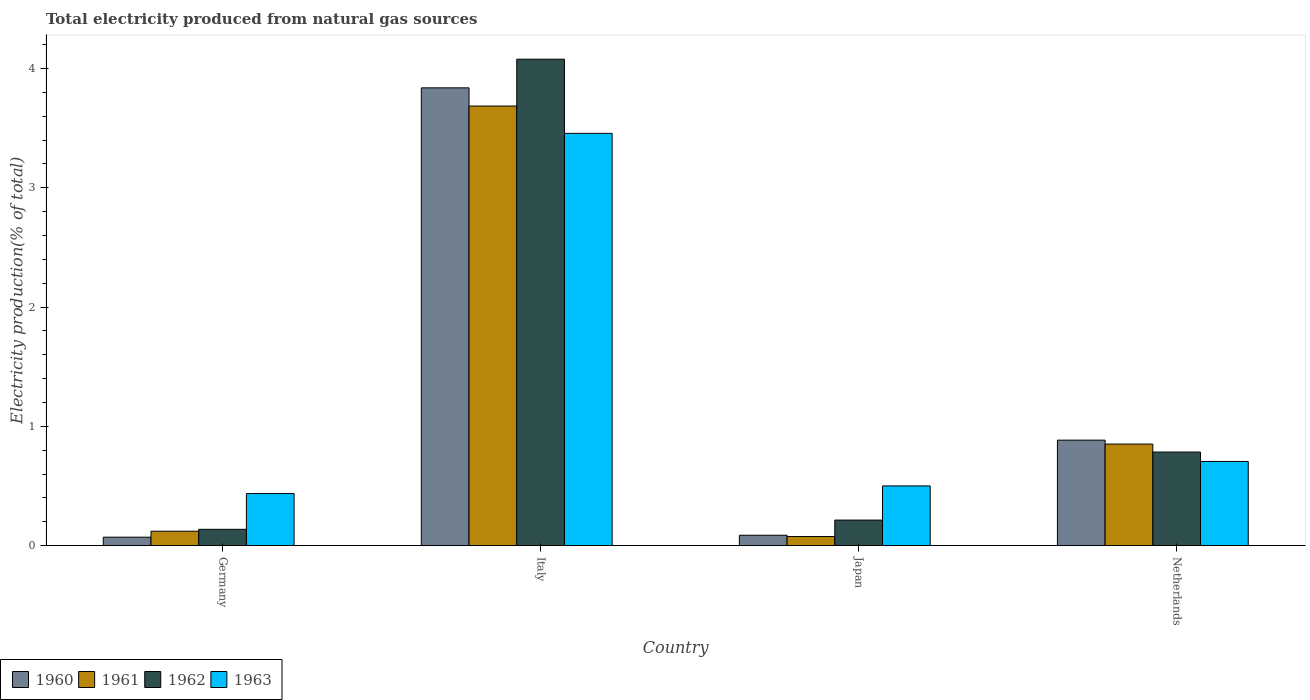Are the number of bars per tick equal to the number of legend labels?
Offer a very short reply. Yes. How many bars are there on the 1st tick from the right?
Provide a succinct answer. 4. What is the label of the 3rd group of bars from the left?
Provide a short and direct response. Japan. In how many cases, is the number of bars for a given country not equal to the number of legend labels?
Provide a short and direct response. 0. What is the total electricity produced in 1960 in Germany?
Offer a terse response. 0.07. Across all countries, what is the maximum total electricity produced in 1960?
Ensure brevity in your answer.  3.84. Across all countries, what is the minimum total electricity produced in 1960?
Provide a succinct answer. 0.07. In which country was the total electricity produced in 1963 maximum?
Provide a succinct answer. Italy. In which country was the total electricity produced in 1961 minimum?
Keep it short and to the point. Japan. What is the total total electricity produced in 1960 in the graph?
Offer a terse response. 4.88. What is the difference between the total electricity produced in 1960 in Japan and that in Netherlands?
Keep it short and to the point. -0.8. What is the difference between the total electricity produced in 1960 in Netherlands and the total electricity produced in 1962 in Japan?
Provide a succinct answer. 0.67. What is the average total electricity produced in 1963 per country?
Keep it short and to the point. 1.27. What is the difference between the total electricity produced of/in 1961 and total electricity produced of/in 1960 in Japan?
Your answer should be very brief. -0.01. In how many countries, is the total electricity produced in 1961 greater than 1.2 %?
Your answer should be compact. 1. What is the ratio of the total electricity produced in 1963 in Italy to that in Netherlands?
Give a very brief answer. 4.9. Is the difference between the total electricity produced in 1961 in Italy and Netherlands greater than the difference between the total electricity produced in 1960 in Italy and Netherlands?
Provide a succinct answer. No. What is the difference between the highest and the second highest total electricity produced in 1963?
Your answer should be very brief. 0.21. What is the difference between the highest and the lowest total electricity produced in 1961?
Ensure brevity in your answer.  3.61. Is the sum of the total electricity produced in 1960 in Italy and Netherlands greater than the maximum total electricity produced in 1961 across all countries?
Keep it short and to the point. Yes. What does the 1st bar from the left in Germany represents?
Your response must be concise. 1960. What does the 3rd bar from the right in Germany represents?
Keep it short and to the point. 1961. Are the values on the major ticks of Y-axis written in scientific E-notation?
Make the answer very short. No. What is the title of the graph?
Give a very brief answer. Total electricity produced from natural gas sources. What is the label or title of the X-axis?
Provide a short and direct response. Country. What is the Electricity production(% of total) of 1960 in Germany?
Provide a succinct answer. 0.07. What is the Electricity production(% of total) in 1961 in Germany?
Your response must be concise. 0.12. What is the Electricity production(% of total) in 1962 in Germany?
Keep it short and to the point. 0.14. What is the Electricity production(% of total) of 1963 in Germany?
Ensure brevity in your answer.  0.44. What is the Electricity production(% of total) of 1960 in Italy?
Provide a succinct answer. 3.84. What is the Electricity production(% of total) in 1961 in Italy?
Your answer should be very brief. 3.69. What is the Electricity production(% of total) in 1962 in Italy?
Your response must be concise. 4.08. What is the Electricity production(% of total) in 1963 in Italy?
Your answer should be very brief. 3.46. What is the Electricity production(% of total) in 1960 in Japan?
Keep it short and to the point. 0.09. What is the Electricity production(% of total) of 1961 in Japan?
Offer a terse response. 0.08. What is the Electricity production(% of total) of 1962 in Japan?
Offer a terse response. 0.21. What is the Electricity production(% of total) of 1963 in Japan?
Offer a terse response. 0.5. What is the Electricity production(% of total) in 1960 in Netherlands?
Offer a terse response. 0.88. What is the Electricity production(% of total) of 1961 in Netherlands?
Keep it short and to the point. 0.85. What is the Electricity production(% of total) in 1962 in Netherlands?
Your response must be concise. 0.78. What is the Electricity production(% of total) of 1963 in Netherlands?
Provide a succinct answer. 0.71. Across all countries, what is the maximum Electricity production(% of total) of 1960?
Provide a short and direct response. 3.84. Across all countries, what is the maximum Electricity production(% of total) in 1961?
Provide a short and direct response. 3.69. Across all countries, what is the maximum Electricity production(% of total) of 1962?
Make the answer very short. 4.08. Across all countries, what is the maximum Electricity production(% of total) in 1963?
Your response must be concise. 3.46. Across all countries, what is the minimum Electricity production(% of total) of 1960?
Make the answer very short. 0.07. Across all countries, what is the minimum Electricity production(% of total) of 1961?
Make the answer very short. 0.08. Across all countries, what is the minimum Electricity production(% of total) in 1962?
Ensure brevity in your answer.  0.14. Across all countries, what is the minimum Electricity production(% of total) in 1963?
Provide a succinct answer. 0.44. What is the total Electricity production(% of total) of 1960 in the graph?
Offer a very short reply. 4.88. What is the total Electricity production(% of total) of 1961 in the graph?
Offer a terse response. 4.73. What is the total Electricity production(% of total) in 1962 in the graph?
Ensure brevity in your answer.  5.21. What is the total Electricity production(% of total) in 1963 in the graph?
Offer a very short reply. 5.1. What is the difference between the Electricity production(% of total) of 1960 in Germany and that in Italy?
Offer a terse response. -3.77. What is the difference between the Electricity production(% of total) of 1961 in Germany and that in Italy?
Your answer should be very brief. -3.57. What is the difference between the Electricity production(% of total) in 1962 in Germany and that in Italy?
Keep it short and to the point. -3.94. What is the difference between the Electricity production(% of total) of 1963 in Germany and that in Italy?
Keep it short and to the point. -3.02. What is the difference between the Electricity production(% of total) in 1960 in Germany and that in Japan?
Make the answer very short. -0.02. What is the difference between the Electricity production(% of total) in 1961 in Germany and that in Japan?
Your answer should be very brief. 0.04. What is the difference between the Electricity production(% of total) of 1962 in Germany and that in Japan?
Provide a short and direct response. -0.08. What is the difference between the Electricity production(% of total) in 1963 in Germany and that in Japan?
Keep it short and to the point. -0.06. What is the difference between the Electricity production(% of total) of 1960 in Germany and that in Netherlands?
Make the answer very short. -0.81. What is the difference between the Electricity production(% of total) in 1961 in Germany and that in Netherlands?
Make the answer very short. -0.73. What is the difference between the Electricity production(% of total) in 1962 in Germany and that in Netherlands?
Your answer should be compact. -0.65. What is the difference between the Electricity production(% of total) of 1963 in Germany and that in Netherlands?
Give a very brief answer. -0.27. What is the difference between the Electricity production(% of total) of 1960 in Italy and that in Japan?
Give a very brief answer. 3.75. What is the difference between the Electricity production(% of total) in 1961 in Italy and that in Japan?
Offer a very short reply. 3.61. What is the difference between the Electricity production(% of total) in 1962 in Italy and that in Japan?
Your answer should be compact. 3.86. What is the difference between the Electricity production(% of total) of 1963 in Italy and that in Japan?
Your response must be concise. 2.96. What is the difference between the Electricity production(% of total) in 1960 in Italy and that in Netherlands?
Keep it short and to the point. 2.95. What is the difference between the Electricity production(% of total) in 1961 in Italy and that in Netherlands?
Give a very brief answer. 2.83. What is the difference between the Electricity production(% of total) in 1962 in Italy and that in Netherlands?
Your answer should be compact. 3.29. What is the difference between the Electricity production(% of total) in 1963 in Italy and that in Netherlands?
Offer a terse response. 2.75. What is the difference between the Electricity production(% of total) in 1960 in Japan and that in Netherlands?
Make the answer very short. -0.8. What is the difference between the Electricity production(% of total) in 1961 in Japan and that in Netherlands?
Ensure brevity in your answer.  -0.78. What is the difference between the Electricity production(% of total) in 1962 in Japan and that in Netherlands?
Offer a terse response. -0.57. What is the difference between the Electricity production(% of total) of 1963 in Japan and that in Netherlands?
Give a very brief answer. -0.21. What is the difference between the Electricity production(% of total) of 1960 in Germany and the Electricity production(% of total) of 1961 in Italy?
Provide a succinct answer. -3.62. What is the difference between the Electricity production(% of total) of 1960 in Germany and the Electricity production(% of total) of 1962 in Italy?
Provide a succinct answer. -4.01. What is the difference between the Electricity production(% of total) of 1960 in Germany and the Electricity production(% of total) of 1963 in Italy?
Your response must be concise. -3.39. What is the difference between the Electricity production(% of total) in 1961 in Germany and the Electricity production(% of total) in 1962 in Italy?
Your response must be concise. -3.96. What is the difference between the Electricity production(% of total) of 1961 in Germany and the Electricity production(% of total) of 1963 in Italy?
Give a very brief answer. -3.34. What is the difference between the Electricity production(% of total) in 1962 in Germany and the Electricity production(% of total) in 1963 in Italy?
Give a very brief answer. -3.32. What is the difference between the Electricity production(% of total) of 1960 in Germany and the Electricity production(% of total) of 1961 in Japan?
Your response must be concise. -0.01. What is the difference between the Electricity production(% of total) of 1960 in Germany and the Electricity production(% of total) of 1962 in Japan?
Provide a succinct answer. -0.14. What is the difference between the Electricity production(% of total) in 1960 in Germany and the Electricity production(% of total) in 1963 in Japan?
Provide a short and direct response. -0.43. What is the difference between the Electricity production(% of total) in 1961 in Germany and the Electricity production(% of total) in 1962 in Japan?
Keep it short and to the point. -0.09. What is the difference between the Electricity production(% of total) in 1961 in Germany and the Electricity production(% of total) in 1963 in Japan?
Ensure brevity in your answer.  -0.38. What is the difference between the Electricity production(% of total) of 1962 in Germany and the Electricity production(% of total) of 1963 in Japan?
Provide a succinct answer. -0.36. What is the difference between the Electricity production(% of total) in 1960 in Germany and the Electricity production(% of total) in 1961 in Netherlands?
Offer a very short reply. -0.78. What is the difference between the Electricity production(% of total) in 1960 in Germany and the Electricity production(% of total) in 1962 in Netherlands?
Make the answer very short. -0.71. What is the difference between the Electricity production(% of total) in 1960 in Germany and the Electricity production(% of total) in 1963 in Netherlands?
Keep it short and to the point. -0.64. What is the difference between the Electricity production(% of total) of 1961 in Germany and the Electricity production(% of total) of 1962 in Netherlands?
Your answer should be compact. -0.66. What is the difference between the Electricity production(% of total) in 1961 in Germany and the Electricity production(% of total) in 1963 in Netherlands?
Your answer should be compact. -0.58. What is the difference between the Electricity production(% of total) in 1962 in Germany and the Electricity production(% of total) in 1963 in Netherlands?
Offer a terse response. -0.57. What is the difference between the Electricity production(% of total) in 1960 in Italy and the Electricity production(% of total) in 1961 in Japan?
Offer a terse response. 3.76. What is the difference between the Electricity production(% of total) of 1960 in Italy and the Electricity production(% of total) of 1962 in Japan?
Your response must be concise. 3.62. What is the difference between the Electricity production(% of total) in 1960 in Italy and the Electricity production(% of total) in 1963 in Japan?
Offer a very short reply. 3.34. What is the difference between the Electricity production(% of total) of 1961 in Italy and the Electricity production(% of total) of 1962 in Japan?
Provide a succinct answer. 3.47. What is the difference between the Electricity production(% of total) of 1961 in Italy and the Electricity production(% of total) of 1963 in Japan?
Keep it short and to the point. 3.19. What is the difference between the Electricity production(% of total) of 1962 in Italy and the Electricity production(% of total) of 1963 in Japan?
Offer a very short reply. 3.58. What is the difference between the Electricity production(% of total) of 1960 in Italy and the Electricity production(% of total) of 1961 in Netherlands?
Make the answer very short. 2.99. What is the difference between the Electricity production(% of total) of 1960 in Italy and the Electricity production(% of total) of 1962 in Netherlands?
Provide a succinct answer. 3.05. What is the difference between the Electricity production(% of total) in 1960 in Italy and the Electricity production(% of total) in 1963 in Netherlands?
Give a very brief answer. 3.13. What is the difference between the Electricity production(% of total) in 1961 in Italy and the Electricity production(% of total) in 1962 in Netherlands?
Keep it short and to the point. 2.9. What is the difference between the Electricity production(% of total) in 1961 in Italy and the Electricity production(% of total) in 1963 in Netherlands?
Provide a succinct answer. 2.98. What is the difference between the Electricity production(% of total) of 1962 in Italy and the Electricity production(% of total) of 1963 in Netherlands?
Provide a short and direct response. 3.37. What is the difference between the Electricity production(% of total) of 1960 in Japan and the Electricity production(% of total) of 1961 in Netherlands?
Keep it short and to the point. -0.76. What is the difference between the Electricity production(% of total) of 1960 in Japan and the Electricity production(% of total) of 1962 in Netherlands?
Make the answer very short. -0.7. What is the difference between the Electricity production(% of total) of 1960 in Japan and the Electricity production(% of total) of 1963 in Netherlands?
Your response must be concise. -0.62. What is the difference between the Electricity production(% of total) of 1961 in Japan and the Electricity production(% of total) of 1962 in Netherlands?
Provide a short and direct response. -0.71. What is the difference between the Electricity production(% of total) in 1961 in Japan and the Electricity production(% of total) in 1963 in Netherlands?
Give a very brief answer. -0.63. What is the difference between the Electricity production(% of total) of 1962 in Japan and the Electricity production(% of total) of 1963 in Netherlands?
Keep it short and to the point. -0.49. What is the average Electricity production(% of total) in 1960 per country?
Keep it short and to the point. 1.22. What is the average Electricity production(% of total) in 1961 per country?
Provide a short and direct response. 1.18. What is the average Electricity production(% of total) in 1962 per country?
Make the answer very short. 1.3. What is the average Electricity production(% of total) in 1963 per country?
Make the answer very short. 1.27. What is the difference between the Electricity production(% of total) in 1960 and Electricity production(% of total) in 1962 in Germany?
Your answer should be very brief. -0.07. What is the difference between the Electricity production(% of total) of 1960 and Electricity production(% of total) of 1963 in Germany?
Give a very brief answer. -0.37. What is the difference between the Electricity production(% of total) of 1961 and Electricity production(% of total) of 1962 in Germany?
Ensure brevity in your answer.  -0.02. What is the difference between the Electricity production(% of total) of 1961 and Electricity production(% of total) of 1963 in Germany?
Provide a short and direct response. -0.32. What is the difference between the Electricity production(% of total) in 1962 and Electricity production(% of total) in 1963 in Germany?
Your answer should be compact. -0.3. What is the difference between the Electricity production(% of total) in 1960 and Electricity production(% of total) in 1961 in Italy?
Offer a very short reply. 0.15. What is the difference between the Electricity production(% of total) in 1960 and Electricity production(% of total) in 1962 in Italy?
Provide a short and direct response. -0.24. What is the difference between the Electricity production(% of total) of 1960 and Electricity production(% of total) of 1963 in Italy?
Ensure brevity in your answer.  0.38. What is the difference between the Electricity production(% of total) of 1961 and Electricity production(% of total) of 1962 in Italy?
Provide a short and direct response. -0.39. What is the difference between the Electricity production(% of total) of 1961 and Electricity production(% of total) of 1963 in Italy?
Make the answer very short. 0.23. What is the difference between the Electricity production(% of total) of 1962 and Electricity production(% of total) of 1963 in Italy?
Offer a very short reply. 0.62. What is the difference between the Electricity production(% of total) in 1960 and Electricity production(% of total) in 1961 in Japan?
Your answer should be compact. 0.01. What is the difference between the Electricity production(% of total) in 1960 and Electricity production(% of total) in 1962 in Japan?
Your response must be concise. -0.13. What is the difference between the Electricity production(% of total) of 1960 and Electricity production(% of total) of 1963 in Japan?
Provide a short and direct response. -0.41. What is the difference between the Electricity production(% of total) of 1961 and Electricity production(% of total) of 1962 in Japan?
Make the answer very short. -0.14. What is the difference between the Electricity production(% of total) of 1961 and Electricity production(% of total) of 1963 in Japan?
Keep it short and to the point. -0.42. What is the difference between the Electricity production(% of total) of 1962 and Electricity production(% of total) of 1963 in Japan?
Provide a short and direct response. -0.29. What is the difference between the Electricity production(% of total) in 1960 and Electricity production(% of total) in 1961 in Netherlands?
Your answer should be very brief. 0.03. What is the difference between the Electricity production(% of total) in 1960 and Electricity production(% of total) in 1962 in Netherlands?
Your response must be concise. 0.1. What is the difference between the Electricity production(% of total) of 1960 and Electricity production(% of total) of 1963 in Netherlands?
Ensure brevity in your answer.  0.18. What is the difference between the Electricity production(% of total) in 1961 and Electricity production(% of total) in 1962 in Netherlands?
Your answer should be compact. 0.07. What is the difference between the Electricity production(% of total) of 1961 and Electricity production(% of total) of 1963 in Netherlands?
Your answer should be compact. 0.15. What is the difference between the Electricity production(% of total) of 1962 and Electricity production(% of total) of 1963 in Netherlands?
Offer a terse response. 0.08. What is the ratio of the Electricity production(% of total) of 1960 in Germany to that in Italy?
Your answer should be very brief. 0.02. What is the ratio of the Electricity production(% of total) of 1961 in Germany to that in Italy?
Provide a short and direct response. 0.03. What is the ratio of the Electricity production(% of total) of 1962 in Germany to that in Italy?
Ensure brevity in your answer.  0.03. What is the ratio of the Electricity production(% of total) of 1963 in Germany to that in Italy?
Ensure brevity in your answer.  0.13. What is the ratio of the Electricity production(% of total) of 1960 in Germany to that in Japan?
Offer a terse response. 0.81. What is the ratio of the Electricity production(% of total) of 1961 in Germany to that in Japan?
Your response must be concise. 1.59. What is the ratio of the Electricity production(% of total) in 1962 in Germany to that in Japan?
Your answer should be very brief. 0.64. What is the ratio of the Electricity production(% of total) in 1963 in Germany to that in Japan?
Your answer should be compact. 0.87. What is the ratio of the Electricity production(% of total) of 1960 in Germany to that in Netherlands?
Your answer should be very brief. 0.08. What is the ratio of the Electricity production(% of total) in 1961 in Germany to that in Netherlands?
Your answer should be very brief. 0.14. What is the ratio of the Electricity production(% of total) in 1962 in Germany to that in Netherlands?
Keep it short and to the point. 0.17. What is the ratio of the Electricity production(% of total) of 1963 in Germany to that in Netherlands?
Offer a very short reply. 0.62. What is the ratio of the Electricity production(% of total) in 1960 in Italy to that in Japan?
Your answer should be compact. 44.33. What is the ratio of the Electricity production(% of total) of 1961 in Italy to that in Japan?
Your response must be concise. 48.69. What is the ratio of the Electricity production(% of total) in 1962 in Italy to that in Japan?
Offer a terse response. 19.09. What is the ratio of the Electricity production(% of total) in 1963 in Italy to that in Japan?
Provide a short and direct response. 6.91. What is the ratio of the Electricity production(% of total) of 1960 in Italy to that in Netherlands?
Provide a succinct answer. 4.34. What is the ratio of the Electricity production(% of total) of 1961 in Italy to that in Netherlands?
Give a very brief answer. 4.33. What is the ratio of the Electricity production(% of total) of 1962 in Italy to that in Netherlands?
Offer a very short reply. 5.2. What is the ratio of the Electricity production(% of total) in 1963 in Italy to that in Netherlands?
Your answer should be very brief. 4.9. What is the ratio of the Electricity production(% of total) in 1960 in Japan to that in Netherlands?
Offer a terse response. 0.1. What is the ratio of the Electricity production(% of total) of 1961 in Japan to that in Netherlands?
Your answer should be compact. 0.09. What is the ratio of the Electricity production(% of total) of 1962 in Japan to that in Netherlands?
Give a very brief answer. 0.27. What is the ratio of the Electricity production(% of total) of 1963 in Japan to that in Netherlands?
Provide a succinct answer. 0.71. What is the difference between the highest and the second highest Electricity production(% of total) in 1960?
Your answer should be very brief. 2.95. What is the difference between the highest and the second highest Electricity production(% of total) in 1961?
Offer a terse response. 2.83. What is the difference between the highest and the second highest Electricity production(% of total) of 1962?
Provide a short and direct response. 3.29. What is the difference between the highest and the second highest Electricity production(% of total) of 1963?
Your answer should be compact. 2.75. What is the difference between the highest and the lowest Electricity production(% of total) in 1960?
Provide a succinct answer. 3.77. What is the difference between the highest and the lowest Electricity production(% of total) of 1961?
Provide a succinct answer. 3.61. What is the difference between the highest and the lowest Electricity production(% of total) of 1962?
Your answer should be very brief. 3.94. What is the difference between the highest and the lowest Electricity production(% of total) of 1963?
Provide a short and direct response. 3.02. 